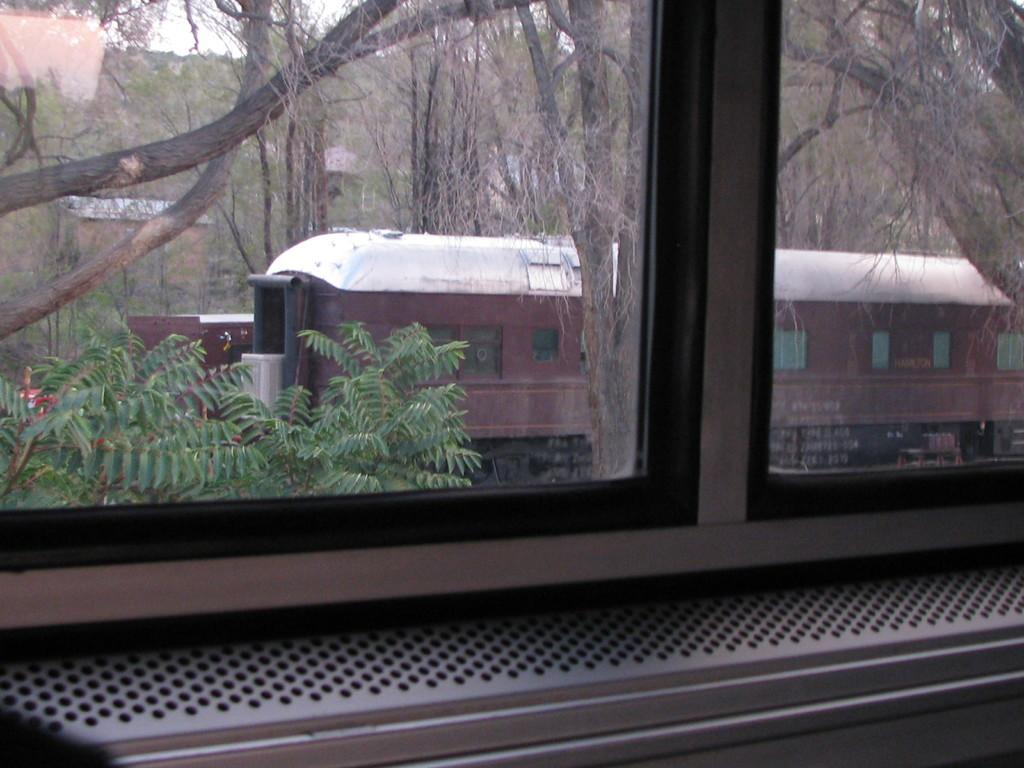What can be seen through the window in the image? Trees are visible through the window in the image. What mode of transportation is present in the image? There is a train in the image. What is the color of the train? The train is brown and white in color. What else can be seen in the image besides the train? There are buildings and the sky visible in the image. What type of quilt is being used to cover the train in the image? There is no quilt present in the image; it features a train and other elements mentioned in the facts. What type of business is being conducted in the image? The image does not depict any business activities; it primarily shows a train, trees, buildings, and the sky. 